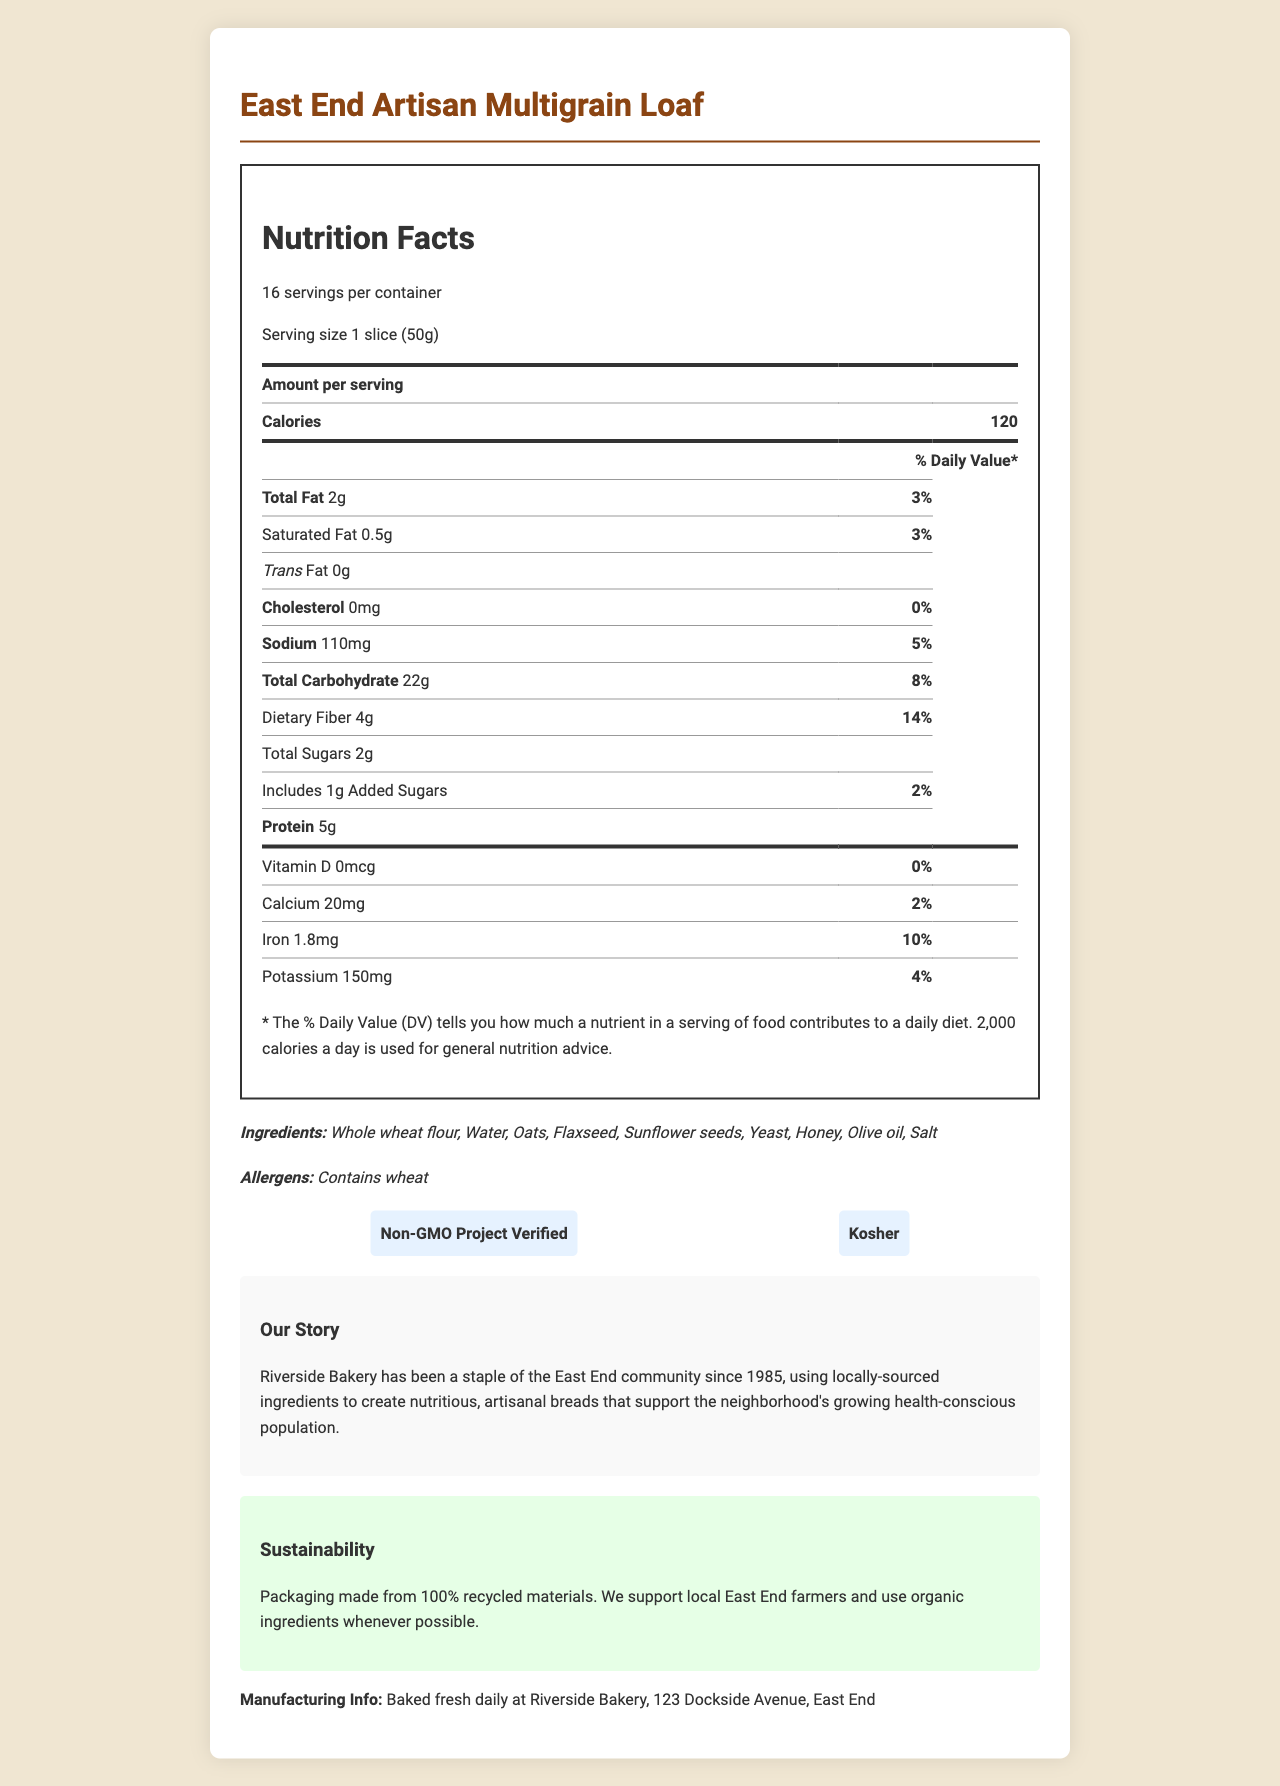what is the serving size of the bread? The serving size is specified as "1 slice (50g)" in the document.
Answer: 1 slice (50g) how many grams of dietary fiber are in a serving? The nutrition label indicates that there are 4 grams of dietary fiber per serving.
Answer: 4g list the main ingredients in the bread. The document provides a list of ingredients under the "Ingredients" section.
Answer: Whole wheat flour, Water, Oats, Flaxseed, Sunflower seeds, Yeast, Honey, Olive oil, Salt what percentage of the daily value of sodium does one serving provide? It is shown in the nutrition facts that the sodium content per serving is 110mg, which is 5% of the daily value.
Answer: 5% where is the bread manufactured? The manufacturing information is provided under "Manufacturing Info."
Answer: Riverside Bakery, 123 Dockside Avenue, East End which of the following is NOT an ingredient in the bread? A. Flaxseed B. Yeast C. Milk D. Honey Milk is not listed under the ingredients, while Flaxseed, Yeast, and Honey are.
Answer: C what percentage of the daily value of iron does one serving provide? The nutrition label indicates that the iron content per serving is 1.8mg, which corresponds to 10% of the daily value.
Answer: 10% who is the manufacturer of the East End Artisan Multigrain Loaf? A. East End Bakery B. Riverside Bakery C. Dockside Bakery D. Artisan Breads The bread is manufactured by Riverside Bakery, as stated in the manufacturing info.
Answer: B does this bread contain trans fat? The nutrition facts indicate that the bread contains 0g of trans fat.
Answer: No is the bread suitable for someone who is allergic to wheat? The allergen information states that the bread contains wheat.
Answer: No summarize the main ideas of the document. The explanation summarizes the overall content and purpose of the document by touching on key points.
Answer: The document provides detailed nutrition facts for the East End Artisan Multigrain Loaf, including information on serving size, calories, and nutrients. It lists the ingredients, allergens, and certifications (Non-GMO and Kosher). The bread is freshly baked daily by Riverside Bakery in the East End, using locally-sourced and organic ingredients when possible. The packaging is eco-friendly, made from recycled materials, and the product aligns with the health-conscious demographic of the East End community. how much protein is in one serving of the bread? The nutrition label states that each serving contains 5g of protein.
Answer: 5g what is a unique feature of Riverside Bakery mentioned in the brand story? The brand story mentions that Riverside Bakery has been part of the community since 1985 and uses locally-sourced ingredients.
Answer: Riverside Bakery has been a staple of the East End community since 1985, using locally-sourced ingredients. how many calories are in a serving of the East End Artisan Multigrain Loaf? The nutrition facts state that there are 120 calories per serving.
Answer: 120 is there any added sugars in this bread? The nutrition facts indicate that there is 1g of added sugars per serving.
Answer: Yes does the bread contain any vitamin D? The nutrition facts indicate that there is 0mcg of Vitamin D per serving.
Answer: No how does the manufacturing of this bread support sustainability? The sustainability note states that the packaging is made from 100% recycled materials. Additionally, the bakery supports local farmers and uses organic ingredients whenever possible.
Answer: Packaging made from 100% recycled materials. when was Riverside Bakery established? The information needed to determine the establishment year of Riverside Bakery is not provided in the document.
Answer: Cannot be determined 